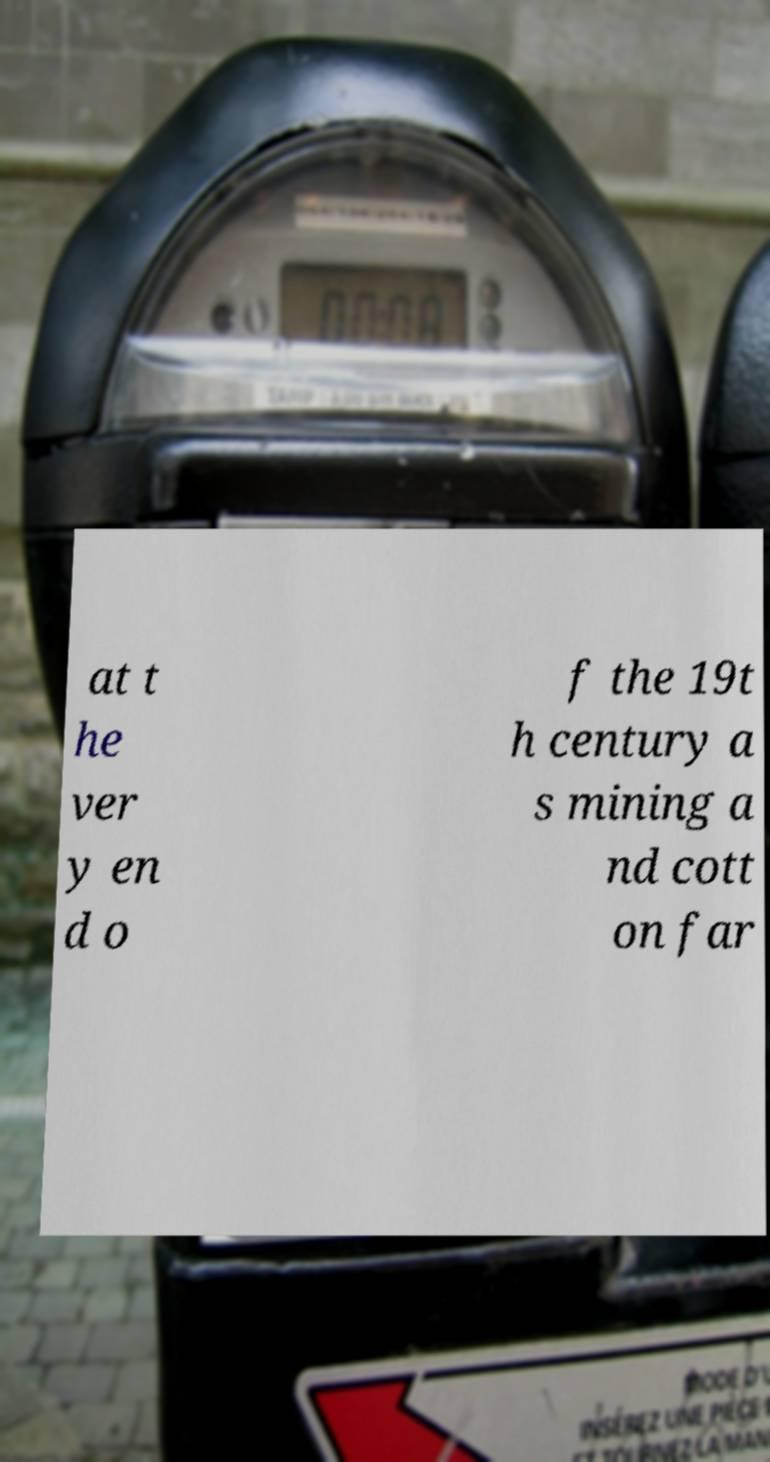Could you extract and type out the text from this image? at t he ver y en d o f the 19t h century a s mining a nd cott on far 